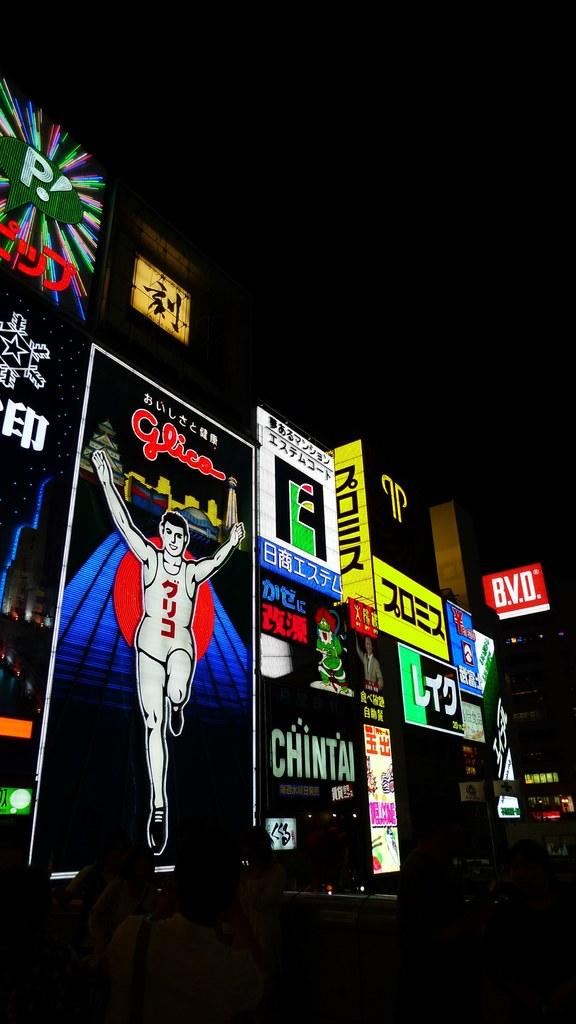<image>
Relay a brief, clear account of the picture shown. Street signs out at night with one saying Chintai. 